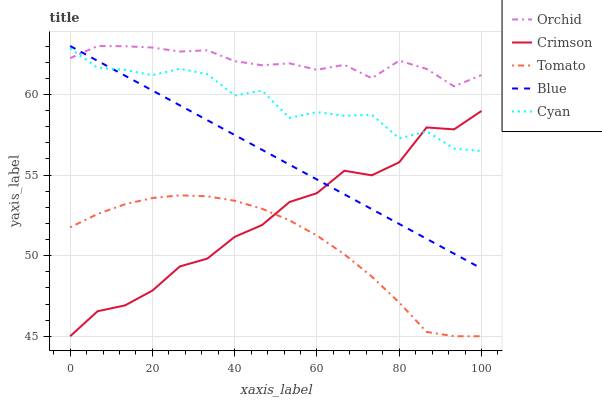Does Tomato have the minimum area under the curve?
Answer yes or no. Yes. Does Orchid have the maximum area under the curve?
Answer yes or no. Yes. Does Cyan have the minimum area under the curve?
Answer yes or no. No. Does Cyan have the maximum area under the curve?
Answer yes or no. No. Is Blue the smoothest?
Answer yes or no. Yes. Is Cyan the roughest?
Answer yes or no. Yes. Is Tomato the smoothest?
Answer yes or no. No. Is Tomato the roughest?
Answer yes or no. No. Does Crimson have the lowest value?
Answer yes or no. Yes. Does Cyan have the lowest value?
Answer yes or no. No. Does Orchid have the highest value?
Answer yes or no. Yes. Does Cyan have the highest value?
Answer yes or no. No. Is Tomato less than Blue?
Answer yes or no. Yes. Is Cyan greater than Tomato?
Answer yes or no. Yes. Does Crimson intersect Cyan?
Answer yes or no. Yes. Is Crimson less than Cyan?
Answer yes or no. No. Is Crimson greater than Cyan?
Answer yes or no. No. Does Tomato intersect Blue?
Answer yes or no. No. 